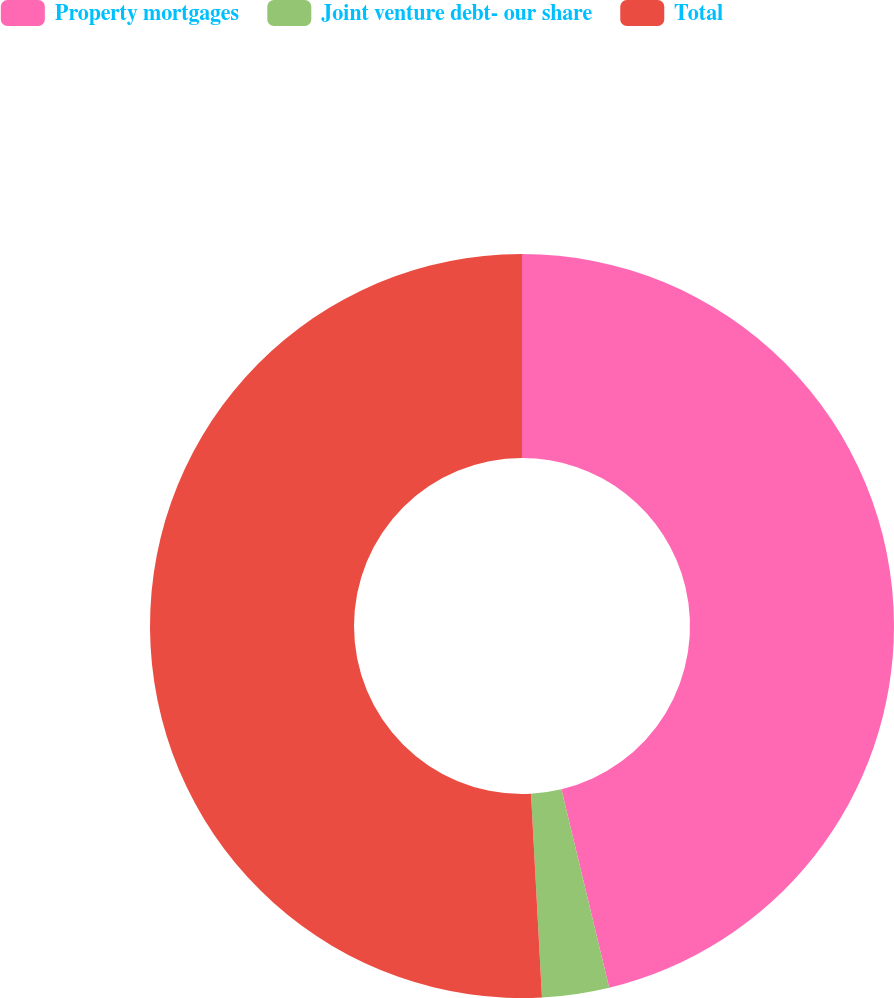Convert chart. <chart><loc_0><loc_0><loc_500><loc_500><pie_chart><fcel>Property mortgages<fcel>Joint venture debt- our share<fcel>Total<nl><fcel>46.23%<fcel>2.91%<fcel>50.85%<nl></chart> 